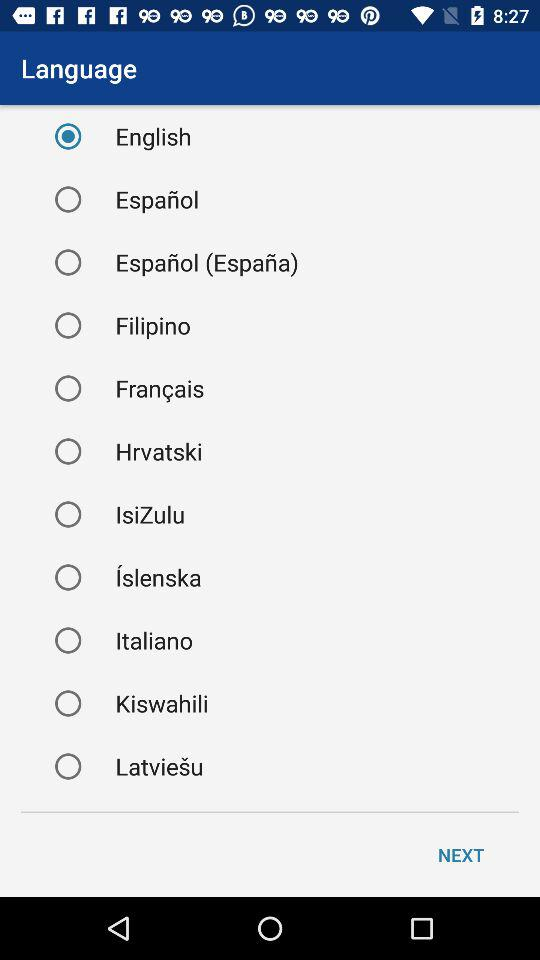What is the selected language? The selected language is English. 